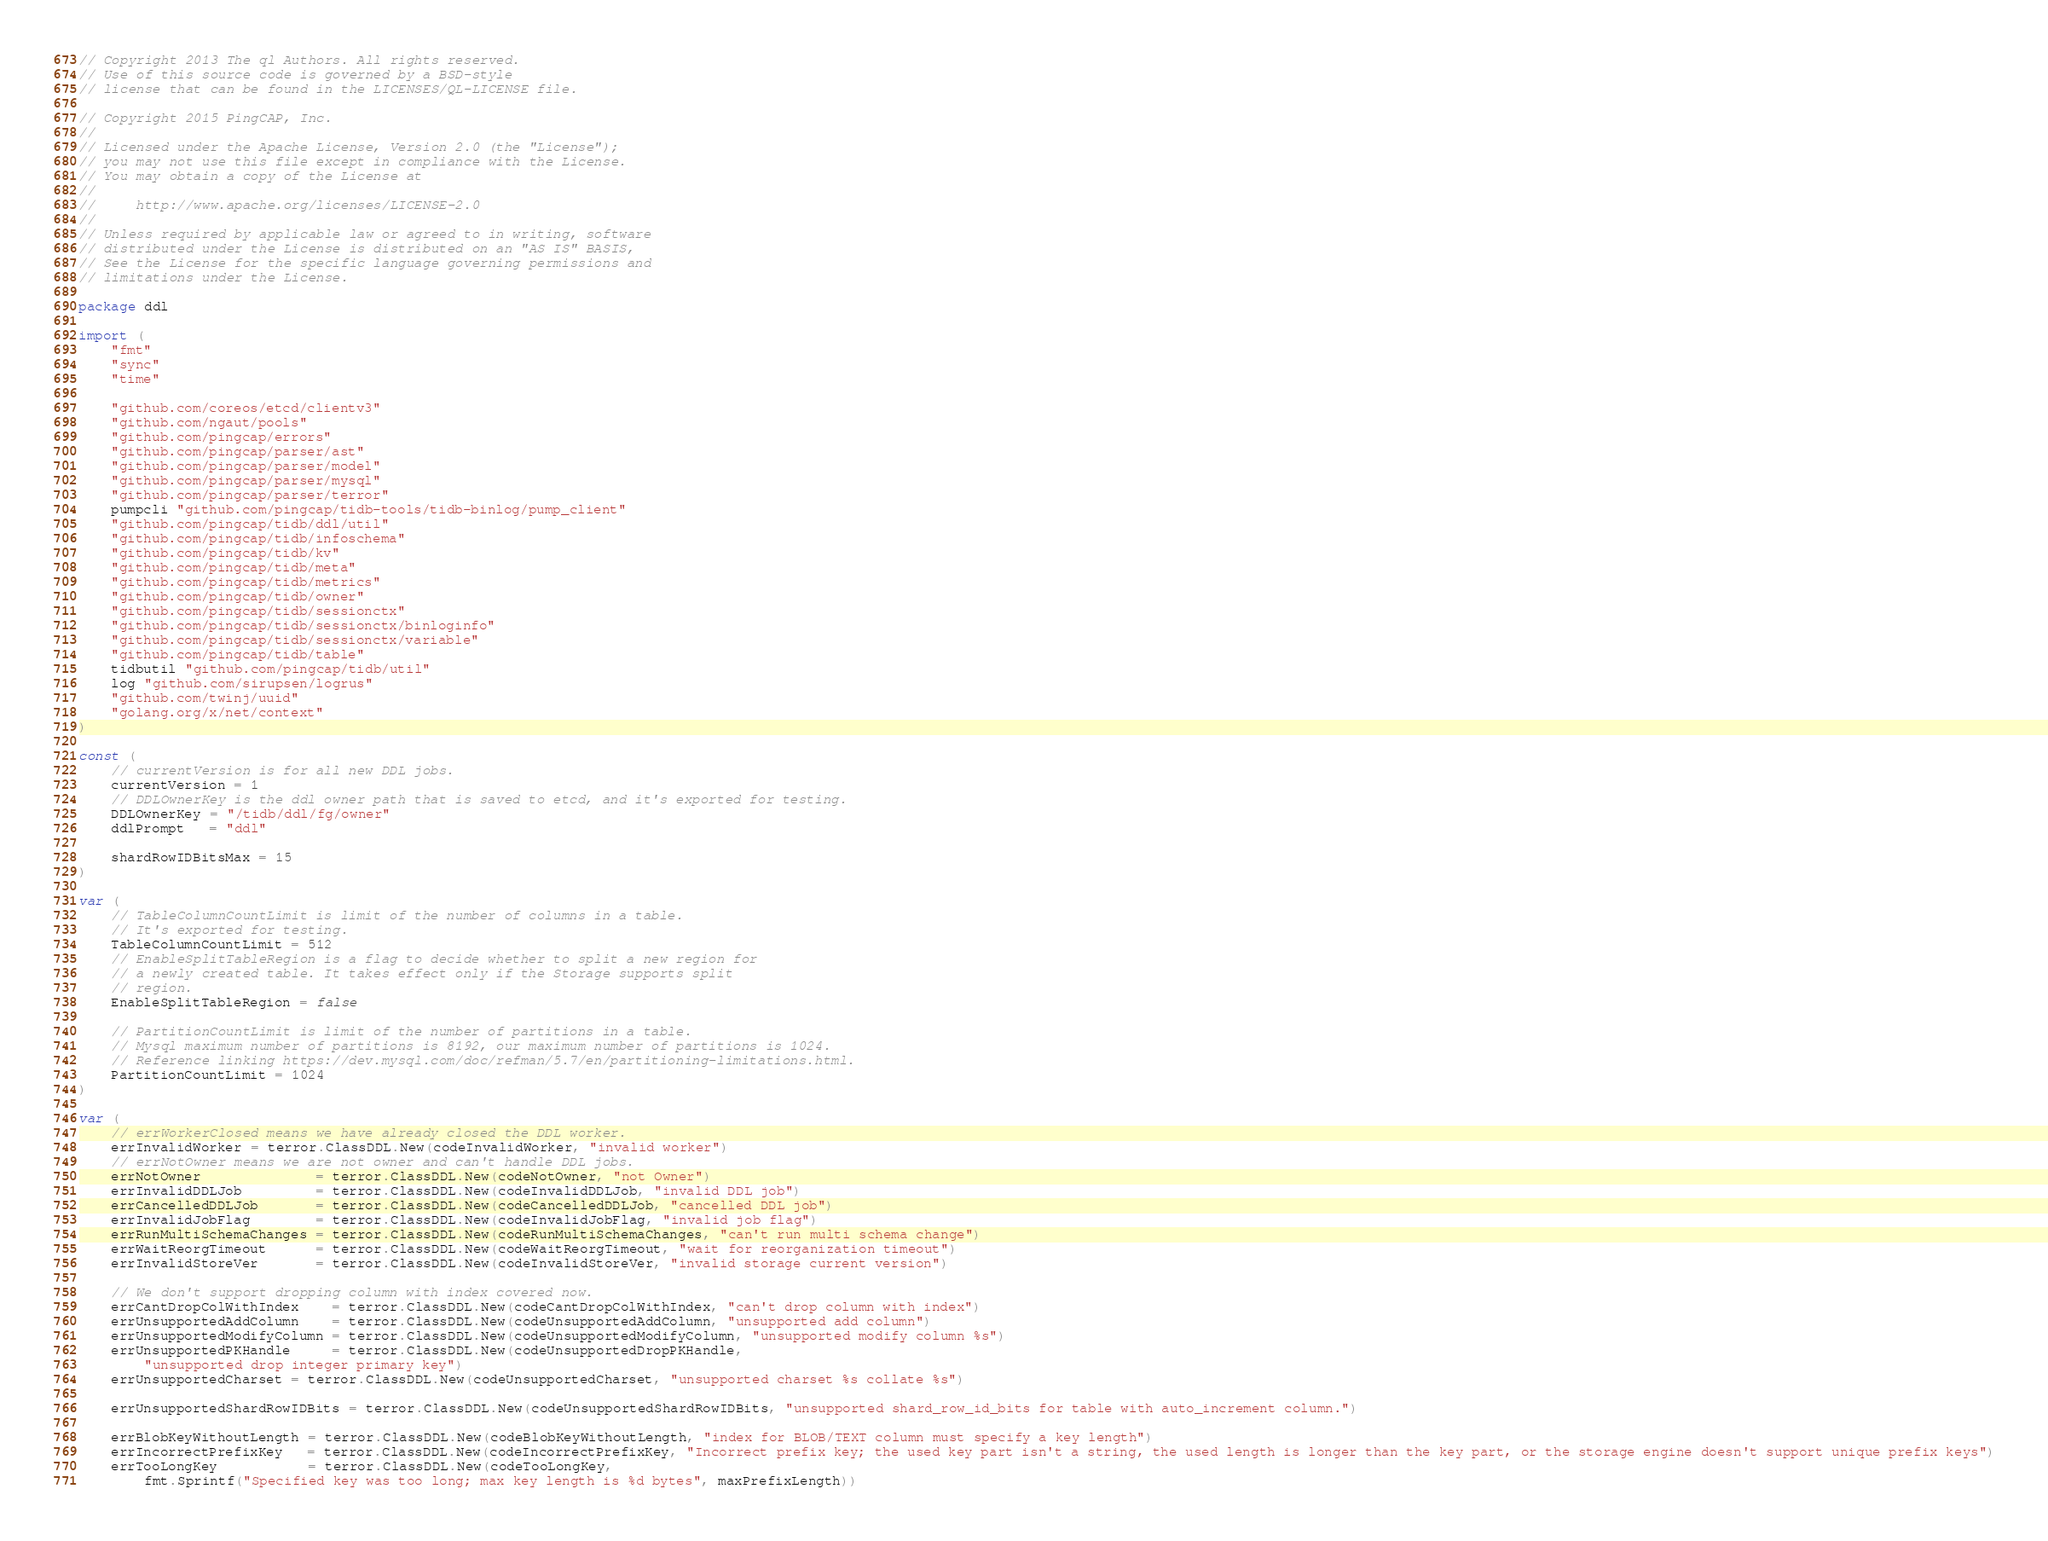Convert code to text. <code><loc_0><loc_0><loc_500><loc_500><_Go_>// Copyright 2013 The ql Authors. All rights reserved.
// Use of this source code is governed by a BSD-style
// license that can be found in the LICENSES/QL-LICENSE file.

// Copyright 2015 PingCAP, Inc.
//
// Licensed under the Apache License, Version 2.0 (the "License");
// you may not use this file except in compliance with the License.
// You may obtain a copy of the License at
//
//     http://www.apache.org/licenses/LICENSE-2.0
//
// Unless required by applicable law or agreed to in writing, software
// distributed under the License is distributed on an "AS IS" BASIS,
// See the License for the specific language governing permissions and
// limitations under the License.

package ddl

import (
	"fmt"
	"sync"
	"time"

	"github.com/coreos/etcd/clientv3"
	"github.com/ngaut/pools"
	"github.com/pingcap/errors"
	"github.com/pingcap/parser/ast"
	"github.com/pingcap/parser/model"
	"github.com/pingcap/parser/mysql"
	"github.com/pingcap/parser/terror"
	pumpcli "github.com/pingcap/tidb-tools/tidb-binlog/pump_client"
	"github.com/pingcap/tidb/ddl/util"
	"github.com/pingcap/tidb/infoschema"
	"github.com/pingcap/tidb/kv"
	"github.com/pingcap/tidb/meta"
	"github.com/pingcap/tidb/metrics"
	"github.com/pingcap/tidb/owner"
	"github.com/pingcap/tidb/sessionctx"
	"github.com/pingcap/tidb/sessionctx/binloginfo"
	"github.com/pingcap/tidb/sessionctx/variable"
	"github.com/pingcap/tidb/table"
	tidbutil "github.com/pingcap/tidb/util"
	log "github.com/sirupsen/logrus"
	"github.com/twinj/uuid"
	"golang.org/x/net/context"
)

const (
	// currentVersion is for all new DDL jobs.
	currentVersion = 1
	// DDLOwnerKey is the ddl owner path that is saved to etcd, and it's exported for testing.
	DDLOwnerKey = "/tidb/ddl/fg/owner"
	ddlPrompt   = "ddl"

	shardRowIDBitsMax = 15
)

var (
	// TableColumnCountLimit is limit of the number of columns in a table.
	// It's exported for testing.
	TableColumnCountLimit = 512
	// EnableSplitTableRegion is a flag to decide whether to split a new region for
	// a newly created table. It takes effect only if the Storage supports split
	// region.
	EnableSplitTableRegion = false

	// PartitionCountLimit is limit of the number of partitions in a table.
	// Mysql maximum number of partitions is 8192, our maximum number of partitions is 1024.
	// Reference linking https://dev.mysql.com/doc/refman/5.7/en/partitioning-limitations.html.
	PartitionCountLimit = 1024
)

var (
	// errWorkerClosed means we have already closed the DDL worker.
	errInvalidWorker = terror.ClassDDL.New(codeInvalidWorker, "invalid worker")
	// errNotOwner means we are not owner and can't handle DDL jobs.
	errNotOwner              = terror.ClassDDL.New(codeNotOwner, "not Owner")
	errInvalidDDLJob         = terror.ClassDDL.New(codeInvalidDDLJob, "invalid DDL job")
	errCancelledDDLJob       = terror.ClassDDL.New(codeCancelledDDLJob, "cancelled DDL job")
	errInvalidJobFlag        = terror.ClassDDL.New(codeInvalidJobFlag, "invalid job flag")
	errRunMultiSchemaChanges = terror.ClassDDL.New(codeRunMultiSchemaChanges, "can't run multi schema change")
	errWaitReorgTimeout      = terror.ClassDDL.New(codeWaitReorgTimeout, "wait for reorganization timeout")
	errInvalidStoreVer       = terror.ClassDDL.New(codeInvalidStoreVer, "invalid storage current version")

	// We don't support dropping column with index covered now.
	errCantDropColWithIndex    = terror.ClassDDL.New(codeCantDropColWithIndex, "can't drop column with index")
	errUnsupportedAddColumn    = terror.ClassDDL.New(codeUnsupportedAddColumn, "unsupported add column")
	errUnsupportedModifyColumn = terror.ClassDDL.New(codeUnsupportedModifyColumn, "unsupported modify column %s")
	errUnsupportedPKHandle     = terror.ClassDDL.New(codeUnsupportedDropPKHandle,
		"unsupported drop integer primary key")
	errUnsupportedCharset = terror.ClassDDL.New(codeUnsupportedCharset, "unsupported charset %s collate %s")

	errUnsupportedShardRowIDBits = terror.ClassDDL.New(codeUnsupportedShardRowIDBits, "unsupported shard_row_id_bits for table with auto_increment column.")

	errBlobKeyWithoutLength = terror.ClassDDL.New(codeBlobKeyWithoutLength, "index for BLOB/TEXT column must specify a key length")
	errIncorrectPrefixKey   = terror.ClassDDL.New(codeIncorrectPrefixKey, "Incorrect prefix key; the used key part isn't a string, the used length is longer than the key part, or the storage engine doesn't support unique prefix keys")
	errTooLongKey           = terror.ClassDDL.New(codeTooLongKey,
		fmt.Sprintf("Specified key was too long; max key length is %d bytes", maxPrefixLength))</code> 